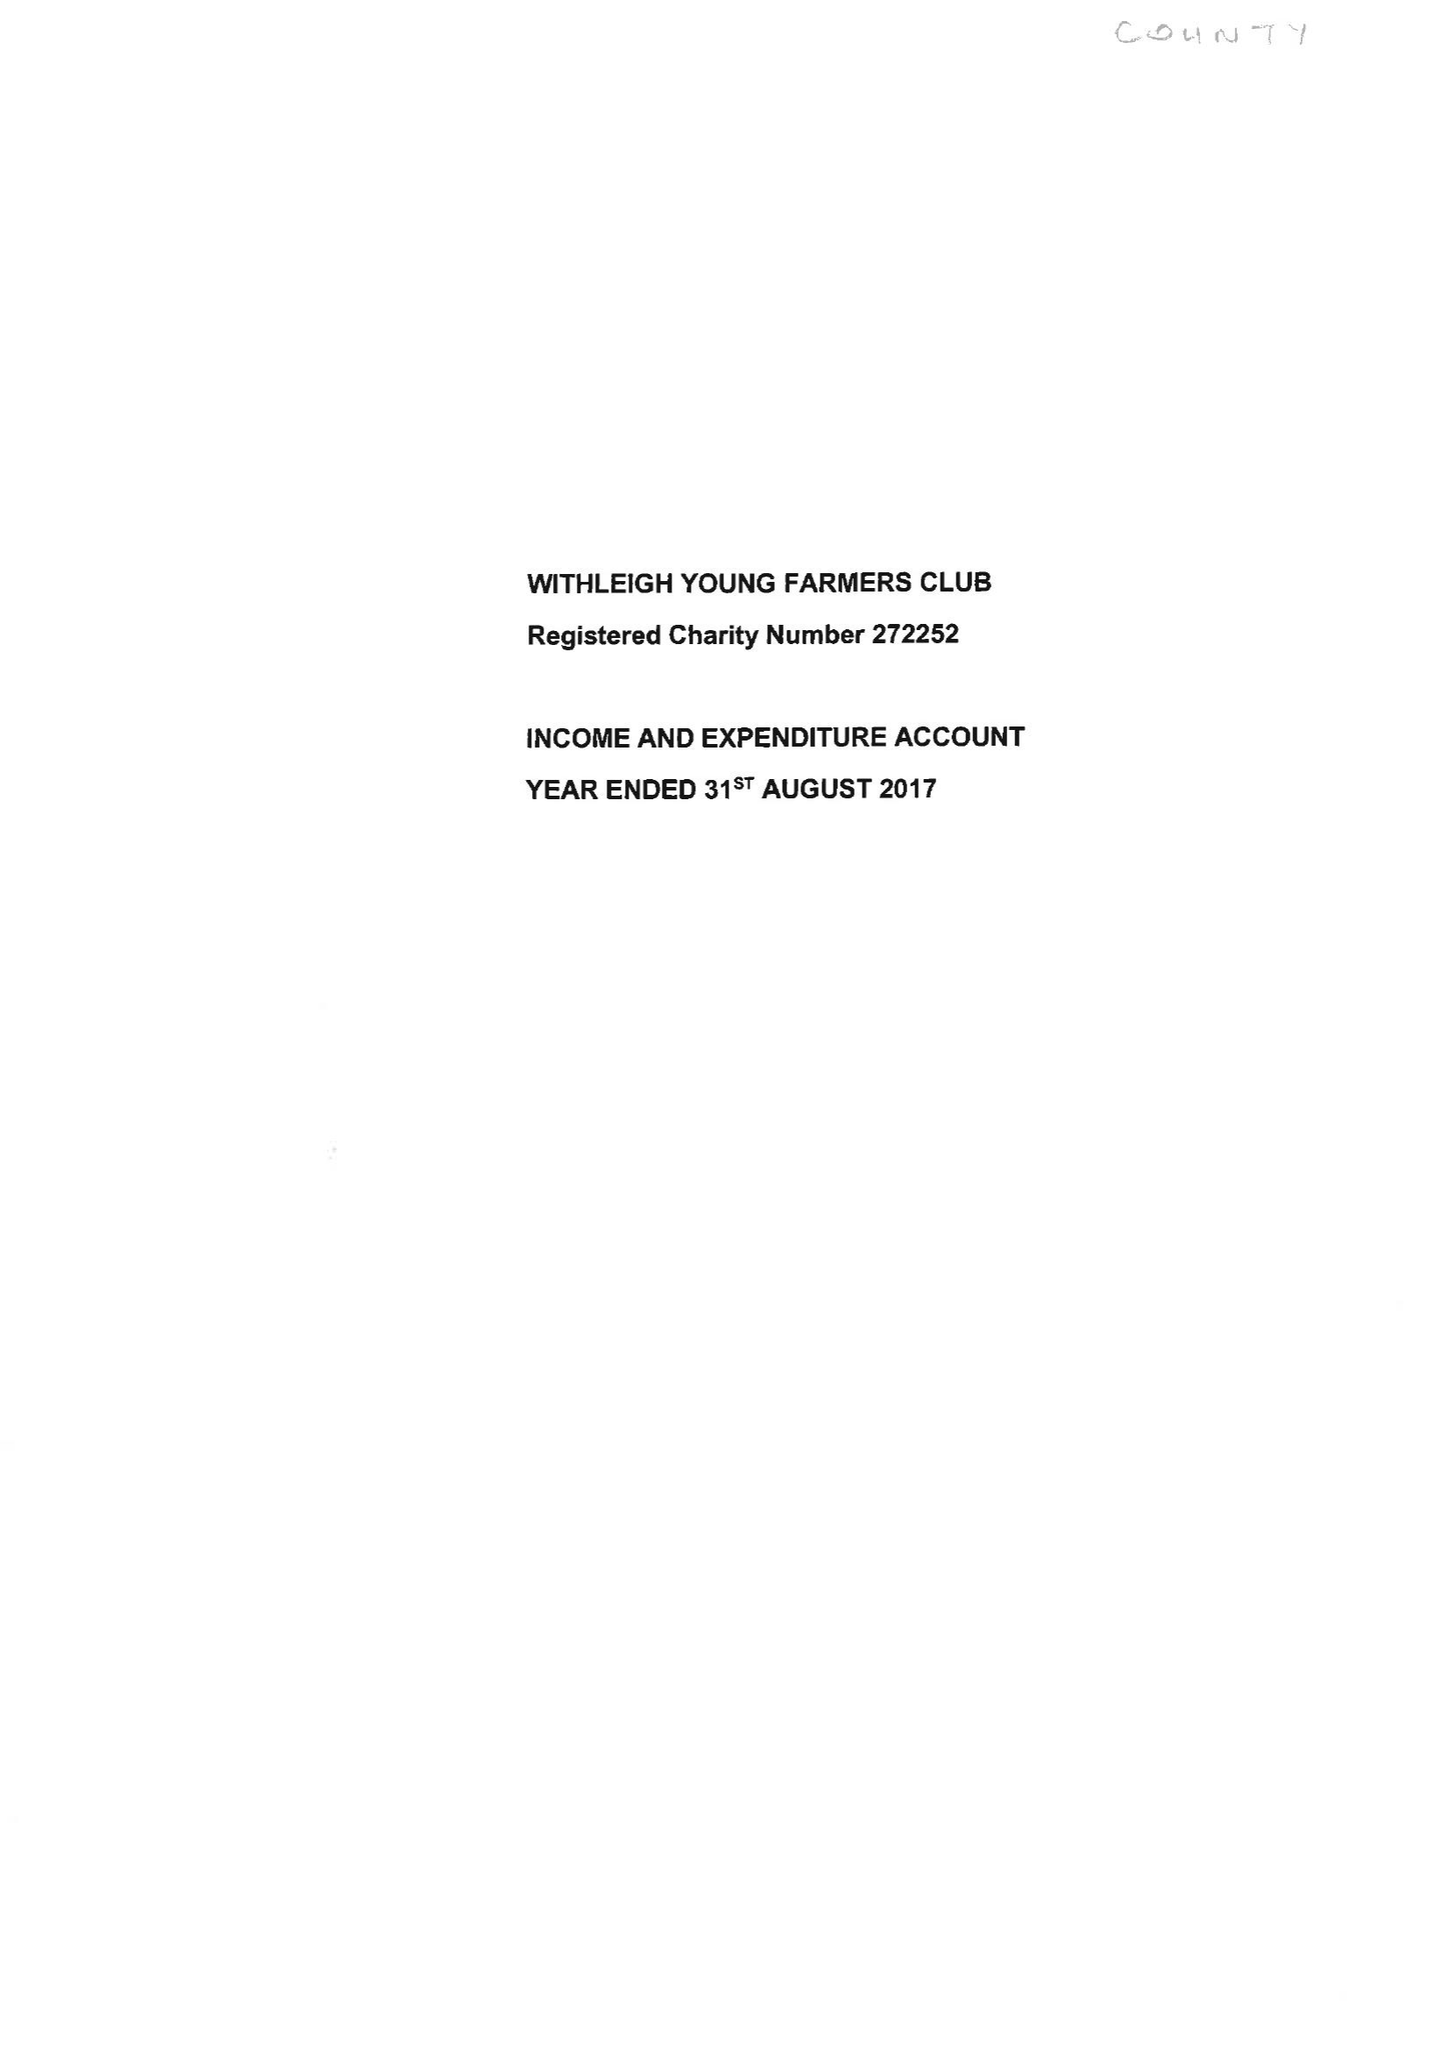What is the value for the address__street_line?
Answer the question using a single word or phrase. None 